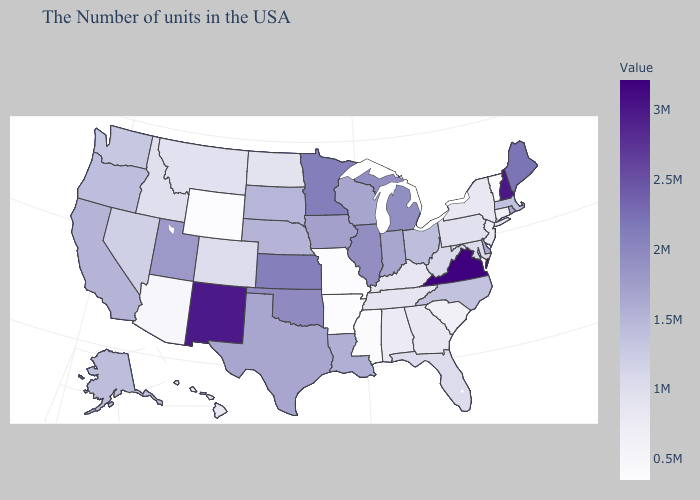Which states have the lowest value in the South?
Answer briefly. Arkansas. Does Virginia have the highest value in the USA?
Be succinct. Yes. Which states have the lowest value in the USA?
Write a very short answer. Vermont, Missouri, Arkansas, Wyoming. 